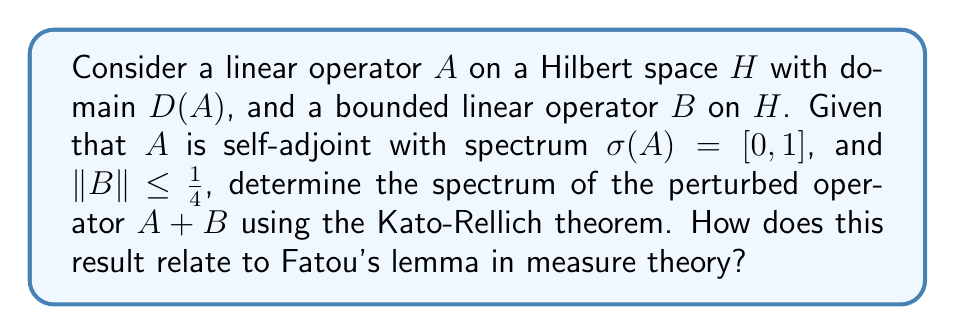Give your solution to this math problem. 1) First, recall the Kato-Rellich theorem: If $A$ is self-adjoint and $B$ is symmetric with $D(A) \subset D(B)$, and there exist constants $a < 1$ and $b \geq 0$ such that $\|Bx\| \leq a\|Ax\| + b\|x\|$ for all $x \in D(A)$, then $A + B$ is self-adjoint with $D(A+B) = D(A)$.

2) In our case, $B$ is bounded, so $D(B) = H \supset D(A)$. Also, $\|Bx\| \leq \|B\|\|x\| \leq \frac{1}{4}\|x\|$ for all $x \in H$.

3) Therefore, we can choose $a = 0$ and $b = \frac{1}{4}$ to satisfy the Kato-Rellich condition.

4) By the Kato-Rellich theorem, $A + B$ is self-adjoint with $D(A+B) = D(A)$.

5) For self-adjoint operators, the spectrum is real. Moreover, for any $\lambda \in \sigma(A+B)$, we have:
   $$\lambda = \langle (A+B)x, x \rangle = \langle Ax, x \rangle + \langle Bx, x \rangle$$
   for some unit vector $x \in H$.

6) Since $\sigma(A) = [0, 1]$, we know that $0 \leq \langle Ax, x \rangle \leq 1$.

7) For the perturbation term: $|\langle Bx, x \rangle| \leq \|B\| \|x\|^2 \leq \frac{1}{4}$.

8) Combining these bounds: $-\frac{1}{4} \leq \lambda \leq \frac{5}{4}$.

9) Therefore, $\sigma(A+B) \subset [-\frac{1}{4}, \frac{5}{4}]$.

10) This result relates to Fatou's lemma in measure theory, which deals with limits of sequences of measurable functions. Both theorems provide bounds on the behavior of perturbed systems, whether in operator theory or measure theory. Fatou's work in complex analysis, which led to Fatou's lemma, shares a common mathematical heritage with spectral theory, both being fundamental to modern analysis.
Answer: $\sigma(A+B) \subset [-\frac{1}{4}, \frac{5}{4}]$ 